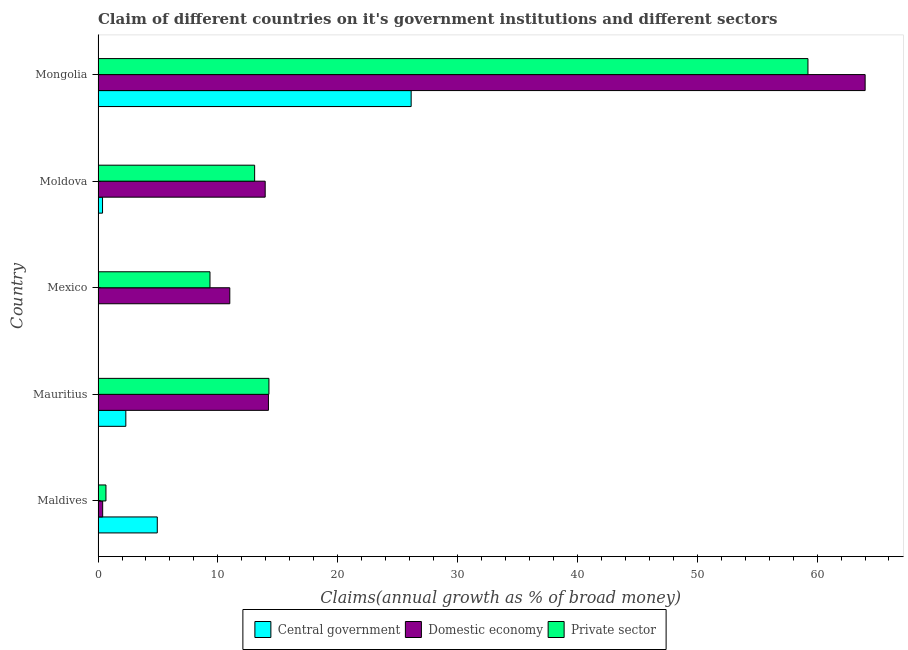How many different coloured bars are there?
Offer a terse response. 3. How many groups of bars are there?
Your answer should be very brief. 5. Are the number of bars on each tick of the Y-axis equal?
Offer a very short reply. No. How many bars are there on the 4th tick from the bottom?
Your answer should be compact. 3. What is the label of the 5th group of bars from the top?
Offer a very short reply. Maldives. In how many cases, is the number of bars for a given country not equal to the number of legend labels?
Offer a terse response. 1. What is the percentage of claim on the private sector in Mauritius?
Ensure brevity in your answer.  14.26. Across all countries, what is the maximum percentage of claim on the central government?
Offer a very short reply. 26.13. Across all countries, what is the minimum percentage of claim on the central government?
Provide a short and direct response. 0. In which country was the percentage of claim on the domestic economy maximum?
Provide a short and direct response. Mongolia. What is the total percentage of claim on the central government in the graph?
Your answer should be very brief. 33.76. What is the difference between the percentage of claim on the private sector in Maldives and that in Mongolia?
Your response must be concise. -58.58. What is the difference between the percentage of claim on the private sector in Mongolia and the percentage of claim on the domestic economy in Mauritius?
Provide a short and direct response. 45.02. What is the average percentage of claim on the central government per country?
Offer a very short reply. 6.75. What is the difference between the percentage of claim on the central government and percentage of claim on the private sector in Moldova?
Your response must be concise. -12.69. In how many countries, is the percentage of claim on the domestic economy greater than 30 %?
Make the answer very short. 1. What is the ratio of the percentage of claim on the domestic economy in Maldives to that in Moldova?
Ensure brevity in your answer.  0.03. What is the difference between the highest and the second highest percentage of claim on the domestic economy?
Provide a short and direct response. 49.79. What is the difference between the highest and the lowest percentage of claim on the domestic economy?
Give a very brief answer. 63.62. How many bars are there?
Give a very brief answer. 14. Are all the bars in the graph horizontal?
Give a very brief answer. Yes. What is the difference between two consecutive major ticks on the X-axis?
Your response must be concise. 10. Are the values on the major ticks of X-axis written in scientific E-notation?
Your answer should be compact. No. Does the graph contain any zero values?
Provide a short and direct response. Yes. Does the graph contain grids?
Your answer should be very brief. No. How are the legend labels stacked?
Provide a succinct answer. Horizontal. What is the title of the graph?
Offer a very short reply. Claim of different countries on it's government institutions and different sectors. Does "Nuclear sources" appear as one of the legend labels in the graph?
Provide a short and direct response. No. What is the label or title of the X-axis?
Offer a terse response. Claims(annual growth as % of broad money). What is the label or title of the Y-axis?
Give a very brief answer. Country. What is the Claims(annual growth as % of broad money) of Central government in Maldives?
Give a very brief answer. 4.94. What is the Claims(annual growth as % of broad money) in Domestic economy in Maldives?
Make the answer very short. 0.39. What is the Claims(annual growth as % of broad money) of Private sector in Maldives?
Ensure brevity in your answer.  0.66. What is the Claims(annual growth as % of broad money) of Central government in Mauritius?
Give a very brief answer. 2.32. What is the Claims(annual growth as % of broad money) of Domestic economy in Mauritius?
Offer a terse response. 14.22. What is the Claims(annual growth as % of broad money) in Private sector in Mauritius?
Offer a very short reply. 14.26. What is the Claims(annual growth as % of broad money) of Domestic economy in Mexico?
Provide a succinct answer. 10.99. What is the Claims(annual growth as % of broad money) of Private sector in Mexico?
Provide a succinct answer. 9.34. What is the Claims(annual growth as % of broad money) in Central government in Moldova?
Keep it short and to the point. 0.37. What is the Claims(annual growth as % of broad money) of Domestic economy in Moldova?
Your answer should be compact. 13.95. What is the Claims(annual growth as % of broad money) of Private sector in Moldova?
Your answer should be compact. 13.07. What is the Claims(annual growth as % of broad money) of Central government in Mongolia?
Make the answer very short. 26.13. What is the Claims(annual growth as % of broad money) of Domestic economy in Mongolia?
Provide a short and direct response. 64.01. What is the Claims(annual growth as % of broad money) of Private sector in Mongolia?
Offer a very short reply. 59.24. Across all countries, what is the maximum Claims(annual growth as % of broad money) in Central government?
Your response must be concise. 26.13. Across all countries, what is the maximum Claims(annual growth as % of broad money) of Domestic economy?
Make the answer very short. 64.01. Across all countries, what is the maximum Claims(annual growth as % of broad money) in Private sector?
Provide a short and direct response. 59.24. Across all countries, what is the minimum Claims(annual growth as % of broad money) in Domestic economy?
Offer a terse response. 0.39. Across all countries, what is the minimum Claims(annual growth as % of broad money) in Private sector?
Provide a short and direct response. 0.66. What is the total Claims(annual growth as % of broad money) of Central government in the graph?
Give a very brief answer. 33.76. What is the total Claims(annual growth as % of broad money) in Domestic economy in the graph?
Your response must be concise. 103.56. What is the total Claims(annual growth as % of broad money) of Private sector in the graph?
Your response must be concise. 96.56. What is the difference between the Claims(annual growth as % of broad money) of Central government in Maldives and that in Mauritius?
Offer a very short reply. 2.63. What is the difference between the Claims(annual growth as % of broad money) in Domestic economy in Maldives and that in Mauritius?
Offer a terse response. -13.83. What is the difference between the Claims(annual growth as % of broad money) of Private sector in Maldives and that in Mauritius?
Keep it short and to the point. -13.6. What is the difference between the Claims(annual growth as % of broad money) in Domestic economy in Maldives and that in Mexico?
Offer a very short reply. -10.61. What is the difference between the Claims(annual growth as % of broad money) in Private sector in Maldives and that in Mexico?
Provide a succinct answer. -8.68. What is the difference between the Claims(annual growth as % of broad money) in Central government in Maldives and that in Moldova?
Ensure brevity in your answer.  4.57. What is the difference between the Claims(annual growth as % of broad money) in Domestic economy in Maldives and that in Moldova?
Give a very brief answer. -13.56. What is the difference between the Claims(annual growth as % of broad money) in Private sector in Maldives and that in Moldova?
Provide a short and direct response. -12.41. What is the difference between the Claims(annual growth as % of broad money) in Central government in Maldives and that in Mongolia?
Make the answer very short. -21.18. What is the difference between the Claims(annual growth as % of broad money) in Domestic economy in Maldives and that in Mongolia?
Make the answer very short. -63.62. What is the difference between the Claims(annual growth as % of broad money) of Private sector in Maldives and that in Mongolia?
Ensure brevity in your answer.  -58.58. What is the difference between the Claims(annual growth as % of broad money) in Domestic economy in Mauritius and that in Mexico?
Your answer should be very brief. 3.22. What is the difference between the Claims(annual growth as % of broad money) of Private sector in Mauritius and that in Mexico?
Provide a short and direct response. 4.92. What is the difference between the Claims(annual growth as % of broad money) in Central government in Mauritius and that in Moldova?
Your answer should be very brief. 1.94. What is the difference between the Claims(annual growth as % of broad money) in Domestic economy in Mauritius and that in Moldova?
Keep it short and to the point. 0.27. What is the difference between the Claims(annual growth as % of broad money) of Private sector in Mauritius and that in Moldova?
Make the answer very short. 1.19. What is the difference between the Claims(annual growth as % of broad money) of Central government in Mauritius and that in Mongolia?
Make the answer very short. -23.81. What is the difference between the Claims(annual growth as % of broad money) of Domestic economy in Mauritius and that in Mongolia?
Make the answer very short. -49.79. What is the difference between the Claims(annual growth as % of broad money) in Private sector in Mauritius and that in Mongolia?
Make the answer very short. -44.98. What is the difference between the Claims(annual growth as % of broad money) of Domestic economy in Mexico and that in Moldova?
Give a very brief answer. -2.95. What is the difference between the Claims(annual growth as % of broad money) in Private sector in Mexico and that in Moldova?
Offer a very short reply. -3.73. What is the difference between the Claims(annual growth as % of broad money) in Domestic economy in Mexico and that in Mongolia?
Make the answer very short. -53.02. What is the difference between the Claims(annual growth as % of broad money) of Private sector in Mexico and that in Mongolia?
Provide a succinct answer. -49.9. What is the difference between the Claims(annual growth as % of broad money) in Central government in Moldova and that in Mongolia?
Your answer should be very brief. -25.75. What is the difference between the Claims(annual growth as % of broad money) of Domestic economy in Moldova and that in Mongolia?
Provide a short and direct response. -50.06. What is the difference between the Claims(annual growth as % of broad money) of Private sector in Moldova and that in Mongolia?
Your answer should be compact. -46.17. What is the difference between the Claims(annual growth as % of broad money) of Central government in Maldives and the Claims(annual growth as % of broad money) of Domestic economy in Mauritius?
Your answer should be compact. -9.28. What is the difference between the Claims(annual growth as % of broad money) of Central government in Maldives and the Claims(annual growth as % of broad money) of Private sector in Mauritius?
Offer a very short reply. -9.32. What is the difference between the Claims(annual growth as % of broad money) of Domestic economy in Maldives and the Claims(annual growth as % of broad money) of Private sector in Mauritius?
Offer a terse response. -13.87. What is the difference between the Claims(annual growth as % of broad money) of Central government in Maldives and the Claims(annual growth as % of broad money) of Domestic economy in Mexico?
Provide a short and direct response. -6.05. What is the difference between the Claims(annual growth as % of broad money) of Central government in Maldives and the Claims(annual growth as % of broad money) of Private sector in Mexico?
Give a very brief answer. -4.4. What is the difference between the Claims(annual growth as % of broad money) in Domestic economy in Maldives and the Claims(annual growth as % of broad money) in Private sector in Mexico?
Offer a very short reply. -8.96. What is the difference between the Claims(annual growth as % of broad money) of Central government in Maldives and the Claims(annual growth as % of broad money) of Domestic economy in Moldova?
Provide a succinct answer. -9. What is the difference between the Claims(annual growth as % of broad money) of Central government in Maldives and the Claims(annual growth as % of broad money) of Private sector in Moldova?
Your answer should be compact. -8.12. What is the difference between the Claims(annual growth as % of broad money) of Domestic economy in Maldives and the Claims(annual growth as % of broad money) of Private sector in Moldova?
Provide a succinct answer. -12.68. What is the difference between the Claims(annual growth as % of broad money) of Central government in Maldives and the Claims(annual growth as % of broad money) of Domestic economy in Mongolia?
Keep it short and to the point. -59.07. What is the difference between the Claims(annual growth as % of broad money) of Central government in Maldives and the Claims(annual growth as % of broad money) of Private sector in Mongolia?
Your answer should be very brief. -54.29. What is the difference between the Claims(annual growth as % of broad money) in Domestic economy in Maldives and the Claims(annual growth as % of broad money) in Private sector in Mongolia?
Offer a very short reply. -58.85. What is the difference between the Claims(annual growth as % of broad money) in Central government in Mauritius and the Claims(annual growth as % of broad money) in Domestic economy in Mexico?
Keep it short and to the point. -8.68. What is the difference between the Claims(annual growth as % of broad money) of Central government in Mauritius and the Claims(annual growth as % of broad money) of Private sector in Mexico?
Give a very brief answer. -7.02. What is the difference between the Claims(annual growth as % of broad money) of Domestic economy in Mauritius and the Claims(annual growth as % of broad money) of Private sector in Mexico?
Offer a terse response. 4.88. What is the difference between the Claims(annual growth as % of broad money) of Central government in Mauritius and the Claims(annual growth as % of broad money) of Domestic economy in Moldova?
Offer a very short reply. -11.63. What is the difference between the Claims(annual growth as % of broad money) of Central government in Mauritius and the Claims(annual growth as % of broad money) of Private sector in Moldova?
Keep it short and to the point. -10.75. What is the difference between the Claims(annual growth as % of broad money) of Domestic economy in Mauritius and the Claims(annual growth as % of broad money) of Private sector in Moldova?
Make the answer very short. 1.15. What is the difference between the Claims(annual growth as % of broad money) of Central government in Mauritius and the Claims(annual growth as % of broad money) of Domestic economy in Mongolia?
Ensure brevity in your answer.  -61.69. What is the difference between the Claims(annual growth as % of broad money) of Central government in Mauritius and the Claims(annual growth as % of broad money) of Private sector in Mongolia?
Your response must be concise. -56.92. What is the difference between the Claims(annual growth as % of broad money) in Domestic economy in Mauritius and the Claims(annual growth as % of broad money) in Private sector in Mongolia?
Your response must be concise. -45.02. What is the difference between the Claims(annual growth as % of broad money) of Domestic economy in Mexico and the Claims(annual growth as % of broad money) of Private sector in Moldova?
Provide a short and direct response. -2.07. What is the difference between the Claims(annual growth as % of broad money) in Domestic economy in Mexico and the Claims(annual growth as % of broad money) in Private sector in Mongolia?
Offer a very short reply. -48.24. What is the difference between the Claims(annual growth as % of broad money) of Central government in Moldova and the Claims(annual growth as % of broad money) of Domestic economy in Mongolia?
Offer a terse response. -63.64. What is the difference between the Claims(annual growth as % of broad money) in Central government in Moldova and the Claims(annual growth as % of broad money) in Private sector in Mongolia?
Keep it short and to the point. -58.86. What is the difference between the Claims(annual growth as % of broad money) of Domestic economy in Moldova and the Claims(annual growth as % of broad money) of Private sector in Mongolia?
Offer a terse response. -45.29. What is the average Claims(annual growth as % of broad money) of Central government per country?
Ensure brevity in your answer.  6.75. What is the average Claims(annual growth as % of broad money) in Domestic economy per country?
Offer a very short reply. 20.71. What is the average Claims(annual growth as % of broad money) of Private sector per country?
Make the answer very short. 19.31. What is the difference between the Claims(annual growth as % of broad money) in Central government and Claims(annual growth as % of broad money) in Domestic economy in Maldives?
Provide a succinct answer. 4.56. What is the difference between the Claims(annual growth as % of broad money) in Central government and Claims(annual growth as % of broad money) in Private sector in Maldives?
Your answer should be compact. 4.28. What is the difference between the Claims(annual growth as % of broad money) of Domestic economy and Claims(annual growth as % of broad money) of Private sector in Maldives?
Provide a succinct answer. -0.27. What is the difference between the Claims(annual growth as % of broad money) of Central government and Claims(annual growth as % of broad money) of Domestic economy in Mauritius?
Keep it short and to the point. -11.9. What is the difference between the Claims(annual growth as % of broad money) in Central government and Claims(annual growth as % of broad money) in Private sector in Mauritius?
Provide a short and direct response. -11.94. What is the difference between the Claims(annual growth as % of broad money) in Domestic economy and Claims(annual growth as % of broad money) in Private sector in Mauritius?
Ensure brevity in your answer.  -0.04. What is the difference between the Claims(annual growth as % of broad money) of Domestic economy and Claims(annual growth as % of broad money) of Private sector in Mexico?
Provide a succinct answer. 1.65. What is the difference between the Claims(annual growth as % of broad money) of Central government and Claims(annual growth as % of broad money) of Domestic economy in Moldova?
Your answer should be very brief. -13.57. What is the difference between the Claims(annual growth as % of broad money) in Central government and Claims(annual growth as % of broad money) in Private sector in Moldova?
Your response must be concise. -12.69. What is the difference between the Claims(annual growth as % of broad money) in Domestic economy and Claims(annual growth as % of broad money) in Private sector in Moldova?
Provide a short and direct response. 0.88. What is the difference between the Claims(annual growth as % of broad money) of Central government and Claims(annual growth as % of broad money) of Domestic economy in Mongolia?
Provide a short and direct response. -37.88. What is the difference between the Claims(annual growth as % of broad money) of Central government and Claims(annual growth as % of broad money) of Private sector in Mongolia?
Your answer should be compact. -33.11. What is the difference between the Claims(annual growth as % of broad money) in Domestic economy and Claims(annual growth as % of broad money) in Private sector in Mongolia?
Make the answer very short. 4.77. What is the ratio of the Claims(annual growth as % of broad money) of Central government in Maldives to that in Mauritius?
Your answer should be very brief. 2.13. What is the ratio of the Claims(annual growth as % of broad money) in Domestic economy in Maldives to that in Mauritius?
Ensure brevity in your answer.  0.03. What is the ratio of the Claims(annual growth as % of broad money) in Private sector in Maldives to that in Mauritius?
Ensure brevity in your answer.  0.05. What is the ratio of the Claims(annual growth as % of broad money) in Domestic economy in Maldives to that in Mexico?
Keep it short and to the point. 0.04. What is the ratio of the Claims(annual growth as % of broad money) of Private sector in Maldives to that in Mexico?
Offer a very short reply. 0.07. What is the ratio of the Claims(annual growth as % of broad money) in Central government in Maldives to that in Moldova?
Make the answer very short. 13.23. What is the ratio of the Claims(annual growth as % of broad money) in Domestic economy in Maldives to that in Moldova?
Your response must be concise. 0.03. What is the ratio of the Claims(annual growth as % of broad money) of Private sector in Maldives to that in Moldova?
Offer a very short reply. 0.05. What is the ratio of the Claims(annual growth as % of broad money) in Central government in Maldives to that in Mongolia?
Provide a short and direct response. 0.19. What is the ratio of the Claims(annual growth as % of broad money) of Domestic economy in Maldives to that in Mongolia?
Keep it short and to the point. 0.01. What is the ratio of the Claims(annual growth as % of broad money) in Private sector in Maldives to that in Mongolia?
Provide a short and direct response. 0.01. What is the ratio of the Claims(annual growth as % of broad money) in Domestic economy in Mauritius to that in Mexico?
Provide a short and direct response. 1.29. What is the ratio of the Claims(annual growth as % of broad money) in Private sector in Mauritius to that in Mexico?
Make the answer very short. 1.53. What is the ratio of the Claims(annual growth as % of broad money) of Central government in Mauritius to that in Moldova?
Offer a terse response. 6.21. What is the ratio of the Claims(annual growth as % of broad money) in Domestic economy in Mauritius to that in Moldova?
Make the answer very short. 1.02. What is the ratio of the Claims(annual growth as % of broad money) in Private sector in Mauritius to that in Moldova?
Your response must be concise. 1.09. What is the ratio of the Claims(annual growth as % of broad money) of Central government in Mauritius to that in Mongolia?
Provide a short and direct response. 0.09. What is the ratio of the Claims(annual growth as % of broad money) of Domestic economy in Mauritius to that in Mongolia?
Offer a very short reply. 0.22. What is the ratio of the Claims(annual growth as % of broad money) of Private sector in Mauritius to that in Mongolia?
Your answer should be very brief. 0.24. What is the ratio of the Claims(annual growth as % of broad money) in Domestic economy in Mexico to that in Moldova?
Give a very brief answer. 0.79. What is the ratio of the Claims(annual growth as % of broad money) of Private sector in Mexico to that in Moldova?
Offer a terse response. 0.71. What is the ratio of the Claims(annual growth as % of broad money) of Domestic economy in Mexico to that in Mongolia?
Offer a terse response. 0.17. What is the ratio of the Claims(annual growth as % of broad money) in Private sector in Mexico to that in Mongolia?
Make the answer very short. 0.16. What is the ratio of the Claims(annual growth as % of broad money) in Central government in Moldova to that in Mongolia?
Your answer should be compact. 0.01. What is the ratio of the Claims(annual growth as % of broad money) of Domestic economy in Moldova to that in Mongolia?
Offer a terse response. 0.22. What is the ratio of the Claims(annual growth as % of broad money) in Private sector in Moldova to that in Mongolia?
Give a very brief answer. 0.22. What is the difference between the highest and the second highest Claims(annual growth as % of broad money) in Central government?
Your answer should be compact. 21.18. What is the difference between the highest and the second highest Claims(annual growth as % of broad money) of Domestic economy?
Your answer should be compact. 49.79. What is the difference between the highest and the second highest Claims(annual growth as % of broad money) of Private sector?
Offer a terse response. 44.98. What is the difference between the highest and the lowest Claims(annual growth as % of broad money) in Central government?
Your answer should be very brief. 26.13. What is the difference between the highest and the lowest Claims(annual growth as % of broad money) in Domestic economy?
Give a very brief answer. 63.62. What is the difference between the highest and the lowest Claims(annual growth as % of broad money) in Private sector?
Offer a terse response. 58.58. 